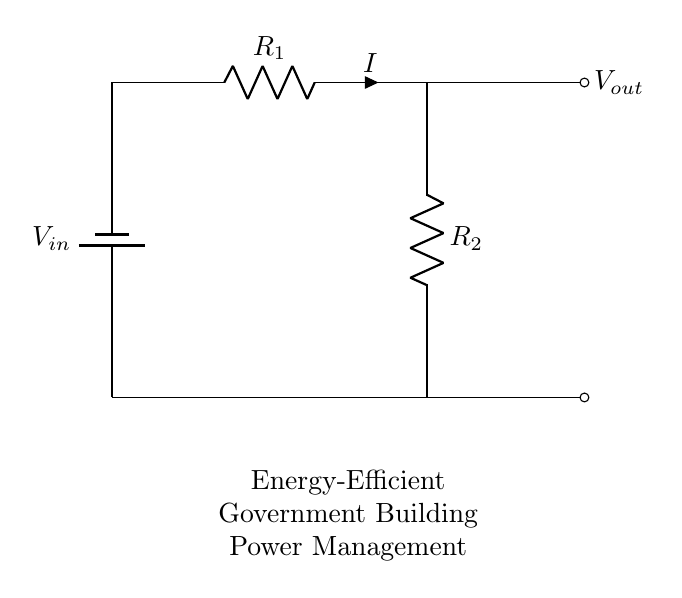What is the input voltage in the circuit? The input voltage is labeled as V_in at the top left of the diagram, indicating the potential supplied to the circuit.
Answer: V_in What are the resistances in this voltage divider? The resistances in the circuit are represented as R_1 and R_2, which are shown in the circuit diagram alongside the symbols for the resistors.
Answer: R_1 and R_2 What is the relationship between V_out and V_in in a voltage divider? The output voltage V_out is derived from the input voltage V_in according to the voltage division rule, which involves the ratio of the resistances R_1 and R_2. Specifically, V_out = V_in * (R_2 / (R_1 + R_2)).
Answer: V_out = V_in * (R_2 / (R_1 + R_2)) How can this circuit enhance energy efficiency in government buildings? The voltage divider enables the control of voltage levels supplied to different loads, reducing energy consumption by matching voltage to the required levels for various components, thus promoting energy efficiency.
Answer: By controlling voltage levels What is the function of the battery in this circuit? The battery provides the necessary input voltage to the circuit, allowing it to function and distribute power according to the designed voltage division.
Answer: To supply V_in How is the current directed through the resistors? The current flows from the battery through resistor R_1, then through R_2, completing the circuit back to the battery. The direction of current flow is indicated by the arrow along the wire connected to R_1.
Answer: From battery to R_1, then R_2 